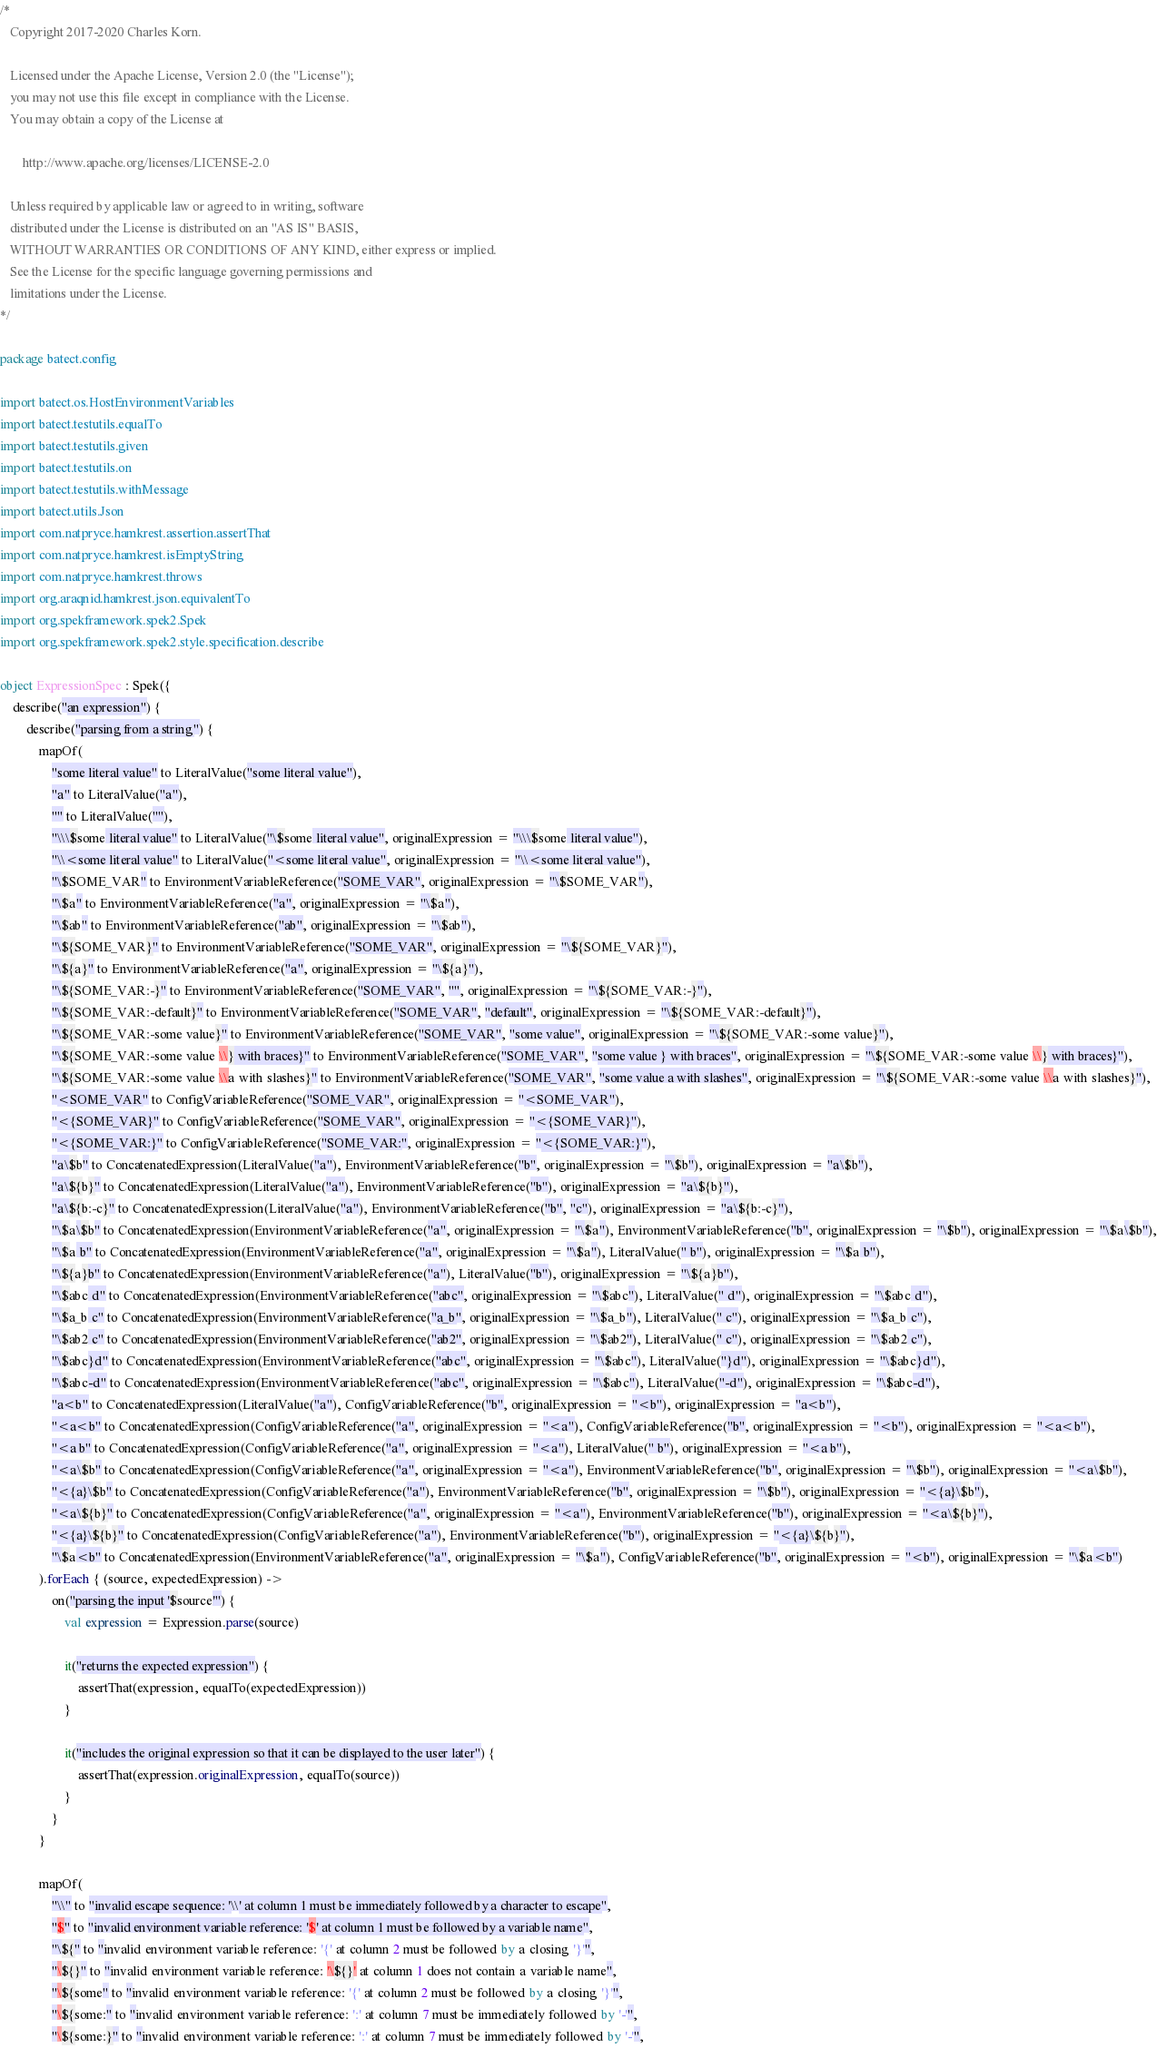Convert code to text. <code><loc_0><loc_0><loc_500><loc_500><_Kotlin_>/*
   Copyright 2017-2020 Charles Korn.

   Licensed under the Apache License, Version 2.0 (the "License");
   you may not use this file except in compliance with the License.
   You may obtain a copy of the License at

       http://www.apache.org/licenses/LICENSE-2.0

   Unless required by applicable law or agreed to in writing, software
   distributed under the License is distributed on an "AS IS" BASIS,
   WITHOUT WARRANTIES OR CONDITIONS OF ANY KIND, either express or implied.
   See the License for the specific language governing permissions and
   limitations under the License.
*/

package batect.config

import batect.os.HostEnvironmentVariables
import batect.testutils.equalTo
import batect.testutils.given
import batect.testutils.on
import batect.testutils.withMessage
import batect.utils.Json
import com.natpryce.hamkrest.assertion.assertThat
import com.natpryce.hamkrest.isEmptyString
import com.natpryce.hamkrest.throws
import org.araqnid.hamkrest.json.equivalentTo
import org.spekframework.spek2.Spek
import org.spekframework.spek2.style.specification.describe

object ExpressionSpec : Spek({
    describe("an expression") {
        describe("parsing from a string") {
            mapOf(
                "some literal value" to LiteralValue("some literal value"),
                "a" to LiteralValue("a"),
                "" to LiteralValue(""),
                "\\\$some literal value" to LiteralValue("\$some literal value", originalExpression = "\\\$some literal value"),
                "\\<some literal value" to LiteralValue("<some literal value", originalExpression = "\\<some literal value"),
                "\$SOME_VAR" to EnvironmentVariableReference("SOME_VAR", originalExpression = "\$SOME_VAR"),
                "\$a" to EnvironmentVariableReference("a", originalExpression = "\$a"),
                "\$ab" to EnvironmentVariableReference("ab", originalExpression = "\$ab"),
                "\${SOME_VAR}" to EnvironmentVariableReference("SOME_VAR", originalExpression = "\${SOME_VAR}"),
                "\${a}" to EnvironmentVariableReference("a", originalExpression = "\${a}"),
                "\${SOME_VAR:-}" to EnvironmentVariableReference("SOME_VAR", "", originalExpression = "\${SOME_VAR:-}"),
                "\${SOME_VAR:-default}" to EnvironmentVariableReference("SOME_VAR", "default", originalExpression = "\${SOME_VAR:-default}"),
                "\${SOME_VAR:-some value}" to EnvironmentVariableReference("SOME_VAR", "some value", originalExpression = "\${SOME_VAR:-some value}"),
                "\${SOME_VAR:-some value \\} with braces}" to EnvironmentVariableReference("SOME_VAR", "some value } with braces", originalExpression = "\${SOME_VAR:-some value \\} with braces}"),
                "\${SOME_VAR:-some value \\a with slashes}" to EnvironmentVariableReference("SOME_VAR", "some value a with slashes", originalExpression = "\${SOME_VAR:-some value \\a with slashes}"),
                "<SOME_VAR" to ConfigVariableReference("SOME_VAR", originalExpression = "<SOME_VAR"),
                "<{SOME_VAR}" to ConfigVariableReference("SOME_VAR", originalExpression = "<{SOME_VAR}"),
                "<{SOME_VAR:}" to ConfigVariableReference("SOME_VAR:", originalExpression = "<{SOME_VAR:}"),
                "a\$b" to ConcatenatedExpression(LiteralValue("a"), EnvironmentVariableReference("b", originalExpression = "\$b"), originalExpression = "a\$b"),
                "a\${b}" to ConcatenatedExpression(LiteralValue("a"), EnvironmentVariableReference("b"), originalExpression = "a\${b}"),
                "a\${b:-c}" to ConcatenatedExpression(LiteralValue("a"), EnvironmentVariableReference("b", "c"), originalExpression = "a\${b:-c}"),
                "\$a\$b" to ConcatenatedExpression(EnvironmentVariableReference("a", originalExpression = "\$a"), EnvironmentVariableReference("b", originalExpression = "\$b"), originalExpression = "\$a\$b"),
                "\$a b" to ConcatenatedExpression(EnvironmentVariableReference("a", originalExpression = "\$a"), LiteralValue(" b"), originalExpression = "\$a b"),
                "\${a}b" to ConcatenatedExpression(EnvironmentVariableReference("a"), LiteralValue("b"), originalExpression = "\${a}b"),
                "\$abc d" to ConcatenatedExpression(EnvironmentVariableReference("abc", originalExpression = "\$abc"), LiteralValue(" d"), originalExpression = "\$abc d"),
                "\$a_b c" to ConcatenatedExpression(EnvironmentVariableReference("a_b", originalExpression = "\$a_b"), LiteralValue(" c"), originalExpression = "\$a_b c"),
                "\$ab2 c" to ConcatenatedExpression(EnvironmentVariableReference("ab2", originalExpression = "\$ab2"), LiteralValue(" c"), originalExpression = "\$ab2 c"),
                "\$abc}d" to ConcatenatedExpression(EnvironmentVariableReference("abc", originalExpression = "\$abc"), LiteralValue("}d"), originalExpression = "\$abc}d"),
                "\$abc-d" to ConcatenatedExpression(EnvironmentVariableReference("abc", originalExpression = "\$abc"), LiteralValue("-d"), originalExpression = "\$abc-d"),
                "a<b" to ConcatenatedExpression(LiteralValue("a"), ConfigVariableReference("b", originalExpression = "<b"), originalExpression = "a<b"),
                "<a<b" to ConcatenatedExpression(ConfigVariableReference("a", originalExpression = "<a"), ConfigVariableReference("b", originalExpression = "<b"), originalExpression = "<a<b"),
                "<a b" to ConcatenatedExpression(ConfigVariableReference("a", originalExpression = "<a"), LiteralValue(" b"), originalExpression = "<a b"),
                "<a\$b" to ConcatenatedExpression(ConfigVariableReference("a", originalExpression = "<a"), EnvironmentVariableReference("b", originalExpression = "\$b"), originalExpression = "<a\$b"),
                "<{a}\$b" to ConcatenatedExpression(ConfigVariableReference("a"), EnvironmentVariableReference("b", originalExpression = "\$b"), originalExpression = "<{a}\$b"),
                "<a\${b}" to ConcatenatedExpression(ConfigVariableReference("a", originalExpression = "<a"), EnvironmentVariableReference("b"), originalExpression = "<a\${b}"),
                "<{a}\${b}" to ConcatenatedExpression(ConfigVariableReference("a"), EnvironmentVariableReference("b"), originalExpression = "<{a}\${b}"),
                "\$a<b" to ConcatenatedExpression(EnvironmentVariableReference("a", originalExpression = "\$a"), ConfigVariableReference("b", originalExpression = "<b"), originalExpression = "\$a<b")
            ).forEach { (source, expectedExpression) ->
                on("parsing the input '$source'") {
                    val expression = Expression.parse(source)

                    it("returns the expected expression") {
                        assertThat(expression, equalTo(expectedExpression))
                    }

                    it("includes the original expression so that it can be displayed to the user later") {
                        assertThat(expression.originalExpression, equalTo(source))
                    }
                }
            }

            mapOf(
                "\\" to "invalid escape sequence: '\\' at column 1 must be immediately followed by a character to escape",
                "$" to "invalid environment variable reference: '$' at column 1 must be followed by a variable name",
                "\${" to "invalid environment variable reference: '{' at column 2 must be followed by a closing '}'",
                "\${}" to "invalid environment variable reference: '\${}' at column 1 does not contain a variable name",
                "\${some" to "invalid environment variable reference: '{' at column 2 must be followed by a closing '}'",
                "\${some:" to "invalid environment variable reference: ':' at column 7 must be immediately followed by '-'",
                "\${some:}" to "invalid environment variable reference: ':' at column 7 must be immediately followed by '-'",</code> 